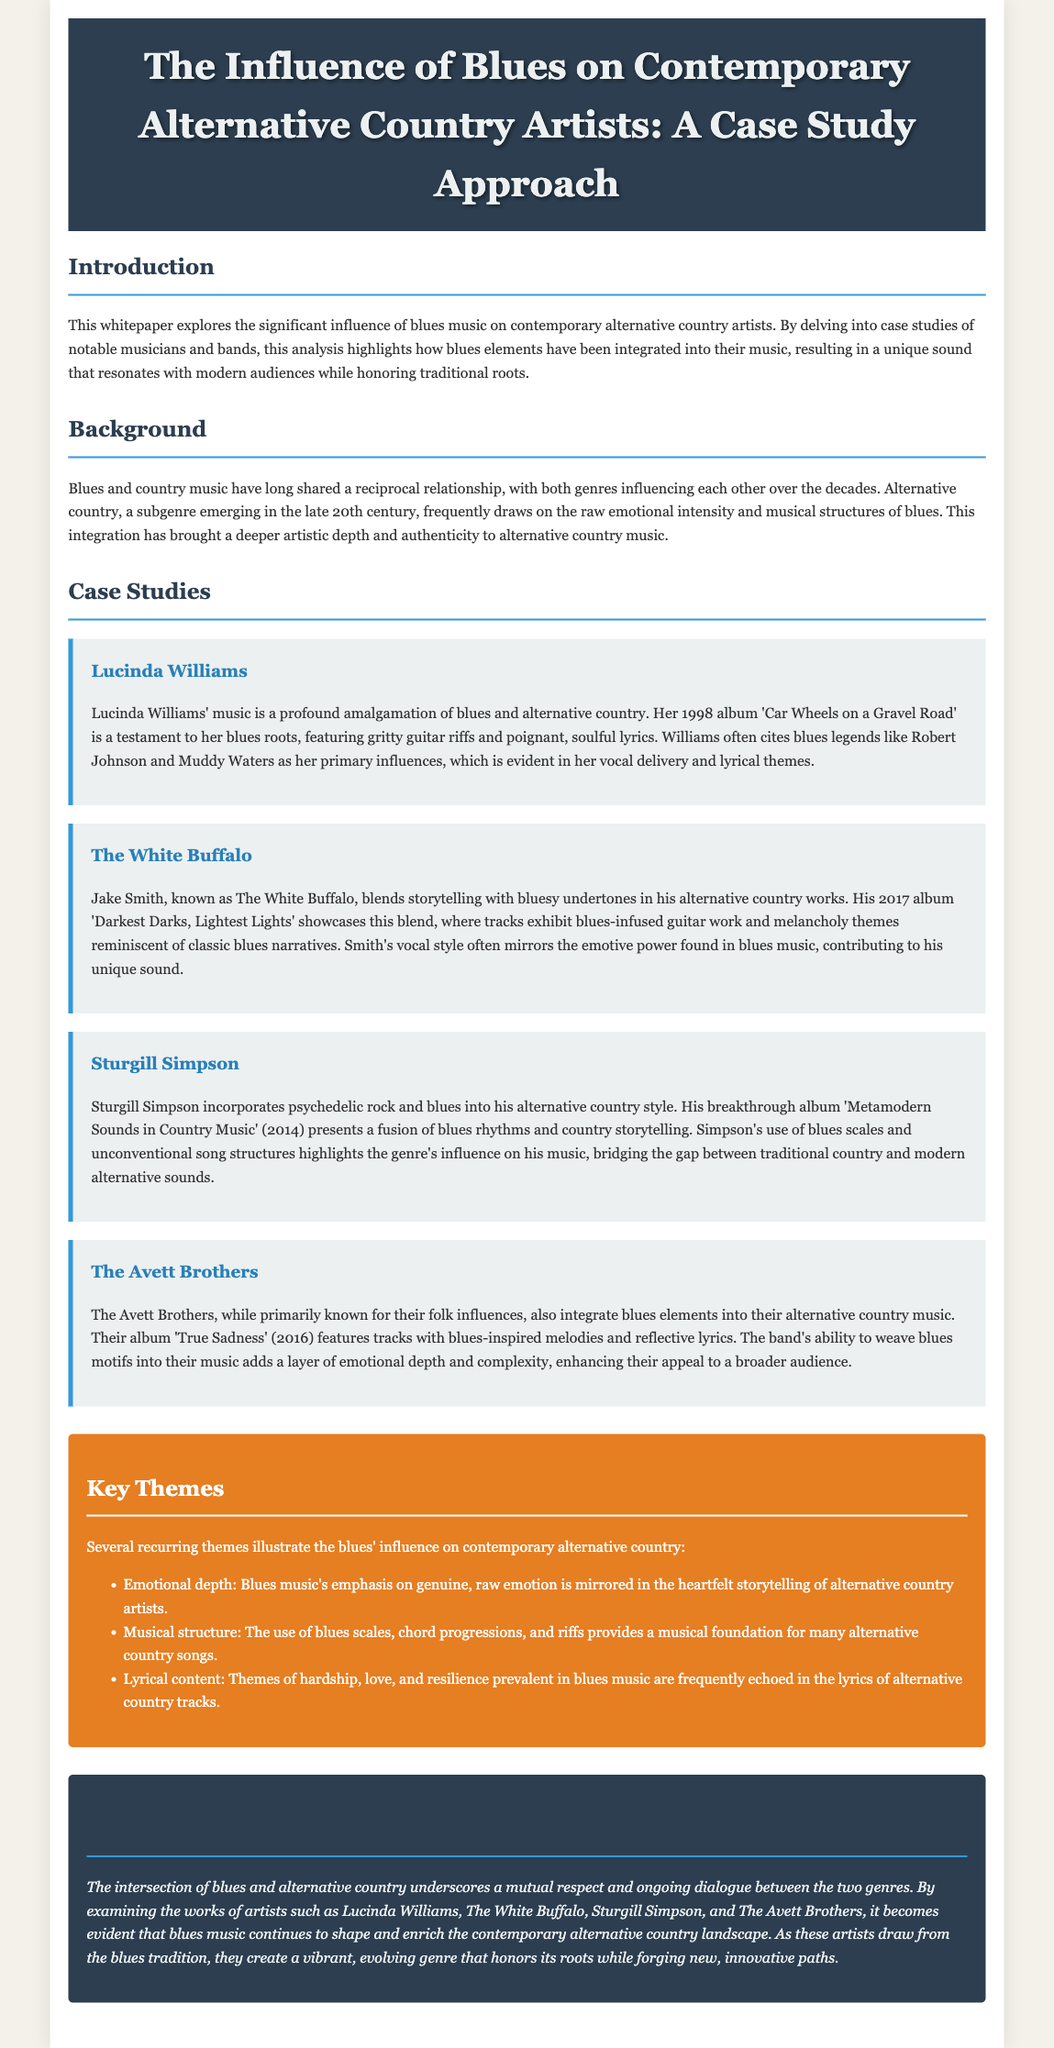What is the title of the whitepaper? The title of the whitepaper is stated in the header section.
Answer: The Influence of Blues on Contemporary Alternative Country Artists: A Case Study Approach Who is an influential artist mentioned in the case studies? The document explicitly lists four artists in its case studies section.
Answer: Lucinda Williams What year was 'Car Wheels on a Gravel Road' released? The release year for the album by Lucinda Williams is mentioned in her case study.
Answer: 1998 Which album features Sturgill Simpson's incorporation of blues? The document references Sturgill Simpson's breakthrough album in his case study.
Answer: Metamodern Sounds in Country Music What is a key theme related to blues music influence in alternative country? The document lists key themes in the 'Key Themes' section.
Answer: Emotional depth How many artists are included in the case studies? The number of artists mentioned can be calculated from the case studies section.
Answer: Four What genre is primarily associated with The Avett Brothers? The Avett Brothers’ main genre is discussed in the case study section.
Answer: Folk What type of music is The White Buffalo known for? The description of Jake Smith in the case study indicates his musical style.
Answer: Alternative country 